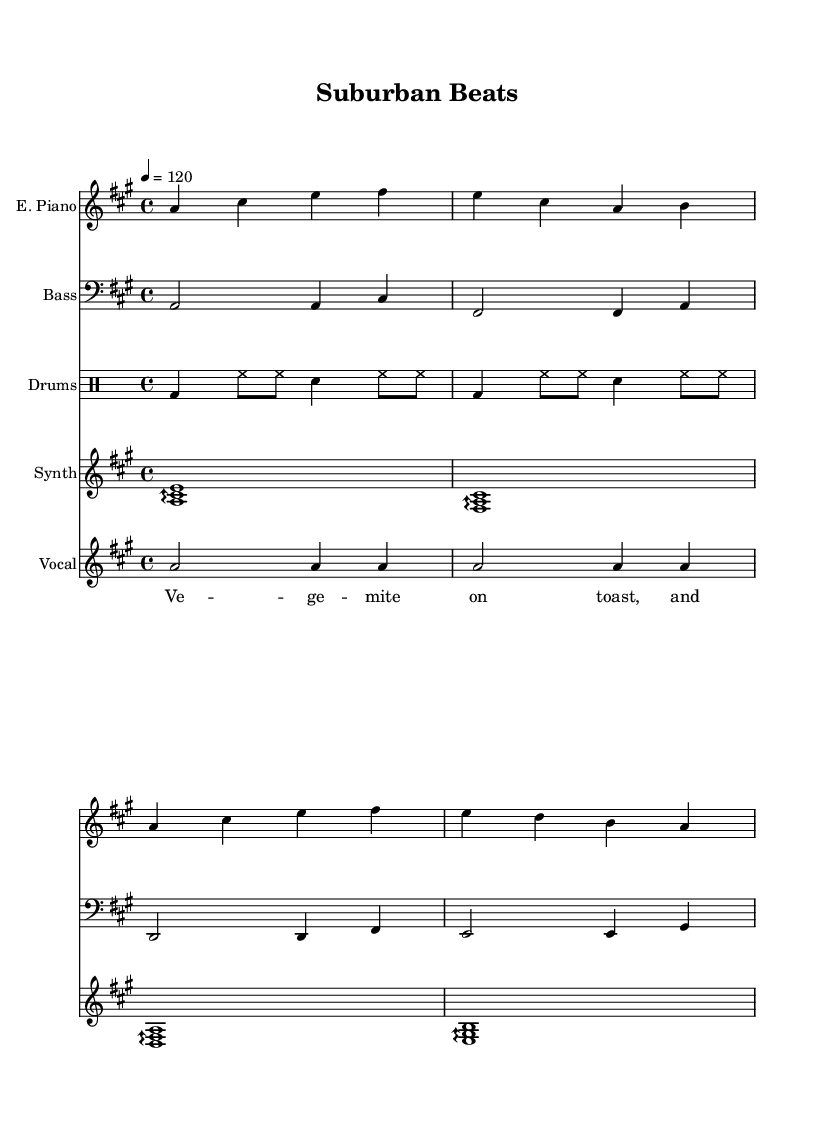What is the key signature of this music? The key signature is A major, which has three sharps: F#, C#, and G#. This is indicated at the beginning of the score where the sharps are notated.
Answer: A major What is the time signature of this music? The time signature is 4/4, which means there are four beats in a measure and the quarter note gets one beat. This is indicated at the beginning of the score, right after the key signature.
Answer: 4/4 What is the tempo marking for this piece? The tempo marking is 120 beats per minute, indicated at the top of the score. The tempo affects how fast or slow the music is played.
Answer: 120 How many measures are in the electric piano section? The electric piano section contains four measures. This can be counted by looking at the vertical lines that separate sections on the staff.
Answer: 4 What type of instrument is playing the melody? The melody is being played by the electric piano, which is indicated at the top of the staff where it states "E. Piano".
Answer: Electric Piano Which instrument plays the bass line in this piece? The bass line is played by the bass guitar, indicated at the start of its staff where it says "Bass." This is a typical instrument for providing harmonic support in dance music.
Answer: Bass Guitar How many distinct vocal lyrics are found in the song? There are six distinct lyrics noted in the vocal line, which is identified in the lyrics section. Each line corresponds to a musical phrase.
Answer: 6 